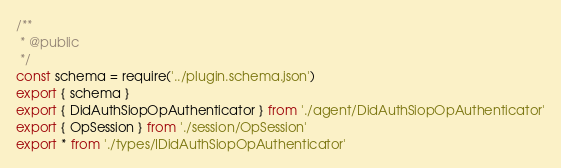Convert code to text. <code><loc_0><loc_0><loc_500><loc_500><_TypeScript_>/**
 * @public
 */
const schema = require('../plugin.schema.json')
export { schema }
export { DidAuthSiopOpAuthenticator } from './agent/DidAuthSiopOpAuthenticator'
export { OpSession } from './session/OpSession'
export * from './types/IDidAuthSiopOpAuthenticator'
</code> 